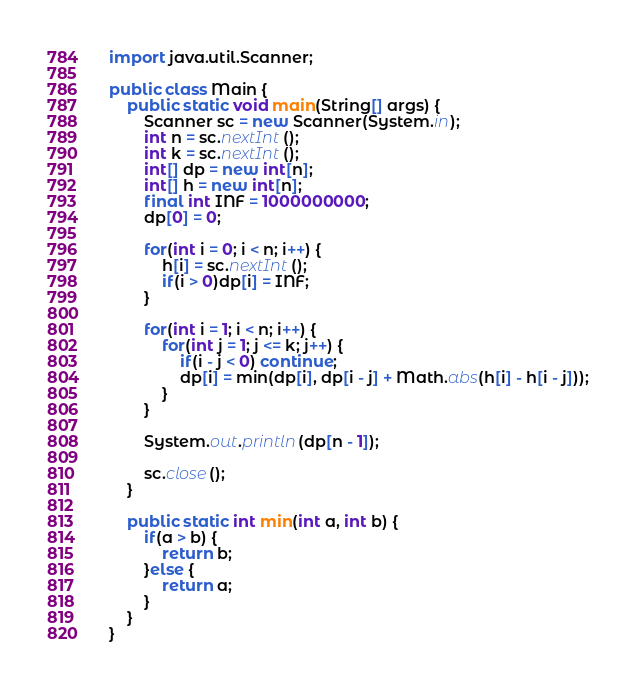<code> <loc_0><loc_0><loc_500><loc_500><_Java_>import java.util.Scanner;

public class Main {
	public static void main(String[] args) {
		Scanner sc = new Scanner(System.in);
		int n = sc.nextInt();
		int k = sc.nextInt();
		int[] dp = new int[n];
		int[] h = new int[n];
		final int INF = 1000000000;
		dp[0] = 0;

		for(int i = 0; i < n; i++) {
			h[i] = sc.nextInt();
			if(i > 0)dp[i] = INF;
		}

		for(int i = 1; i < n; i++) {
			for(int j = 1; j <= k; j++) {
				if(i - j < 0) continue;
				dp[i] = min(dp[i], dp[i - j] + Math.abs(h[i] - h[i - j]));
			}
		}

		System.out.println(dp[n - 1]);

		sc.close();
	}

	public static int min(int a, int b) {
		if(a > b) {
			return b;
		}else {
			return a;
		}
	}
}
</code> 